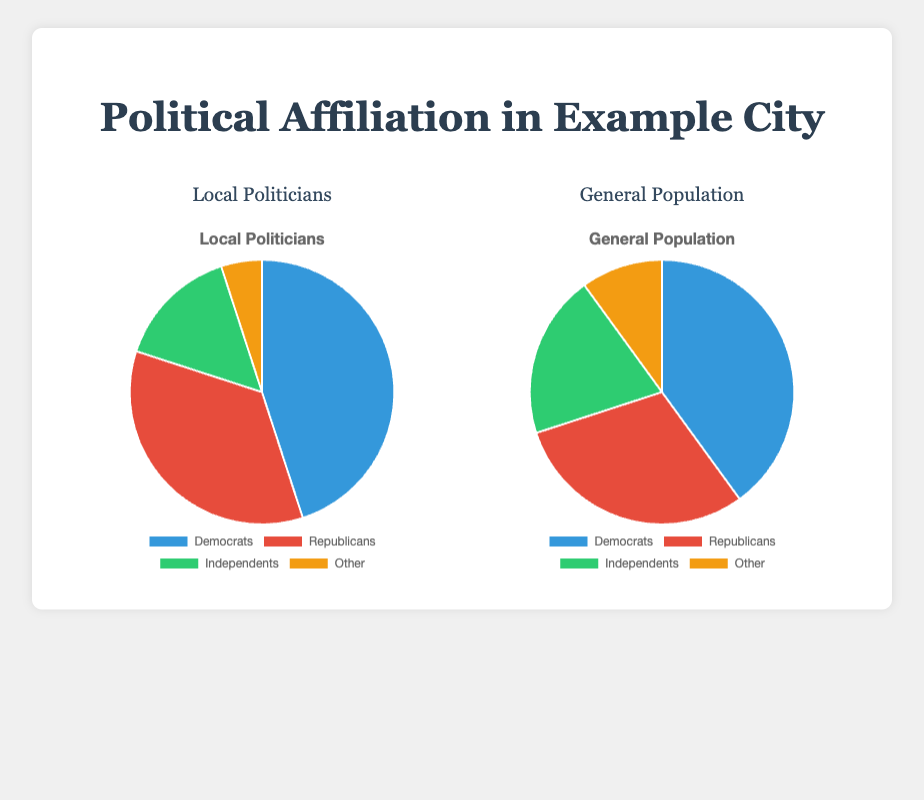Which group has a higher percentage of Democrats, local politicians or the general population? To determine this, we can compare the percentage of Democrats in each group. Local politicians have 45% Democrats, while the general population has 40% Democrats.
Answer: Local politicians What is the difference in the percentage of Independents between local politicians and the general population? The percentage of Independents among local politicians is 15%, and for the general population, it is 20%. Subtracting these values gives us the difference (20% - 15%) = 5%.
Answer: 5% Which category has the smallest percentage in both local politicians and the general population? We need to look at the percentages for each category and identify the smallest ones. For local politicians, the smallest percentage is "Other" with 5%. For the general population, it's also "Other" with 10%. Comparing these two, "Other" is the smallest in both groups, but 5% is smaller compared to 10%
Answer: Other By what percentage do Republicans among local politicians exceed Republicans in the general population? Local politicians have 35% Republicans, while the general population has 30% Republicans. Subtract the 30% from 35% to find the exceed percentage (35% - 30%) = 5%.
Answer: 5% What is the total percentage of Democrats and Republicans in the general population? The percentage of Democrats in the general population is 40%, and the Republicans make up 30%. Adding these together gives us 40% + 30% = 70%.
Answer: 70% How much larger is the percentage of "Other" in the general population compared to local politicians? "Other" comprises 10% of the general population and 5% of the local politicians. Subtract these values to find the difference (10% - 5%) = 5%.
Answer: 5% Compare the combined percentage of Independents and Others in both groups. Which has a higher combined percentage? For local politicians, Independents (15%) + Other (5%) = 20%. For the general population, Independents (20%) + Other (10%) = 30%. The general population has a higher combined percentage.
Answer: General Population What is the combined percentage of Independents and Others among local politicians? Adding the percentage of Independents (15%) and Others (5%) among local politicians, 15% + 5% = 20%.
Answer: 20% Which political affiliation has the closest percentage between local politicians and the general population? We compare the differences for each party: Democrats (45% vs 40%) = 5%, Republicans (35% vs 30%) = 5%, Independents (15% vs 20%) = 5%, Other (5% vs 10%) = 5%. All differences are identical, at 5%.
Answer: All are equal 